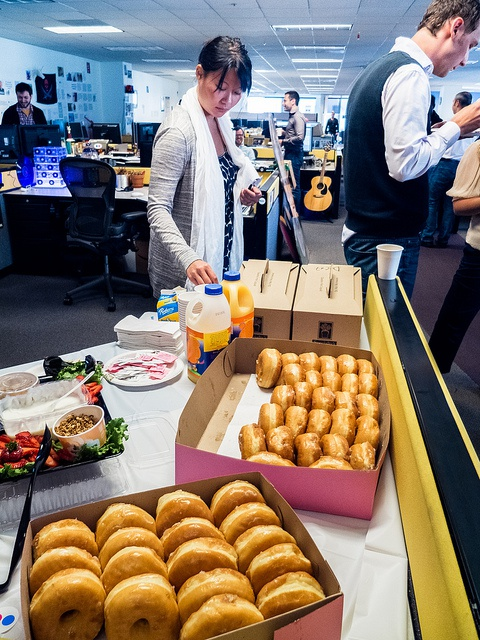Describe the objects in this image and their specific colors. I can see donut in teal, brown, orange, and maroon tones, people in teal, black, lightgray, navy, and gray tones, people in teal, lightgray, gray, darkgray, and black tones, chair in teal, black, navy, darkblue, and gray tones, and people in teal, black, tan, and brown tones in this image. 